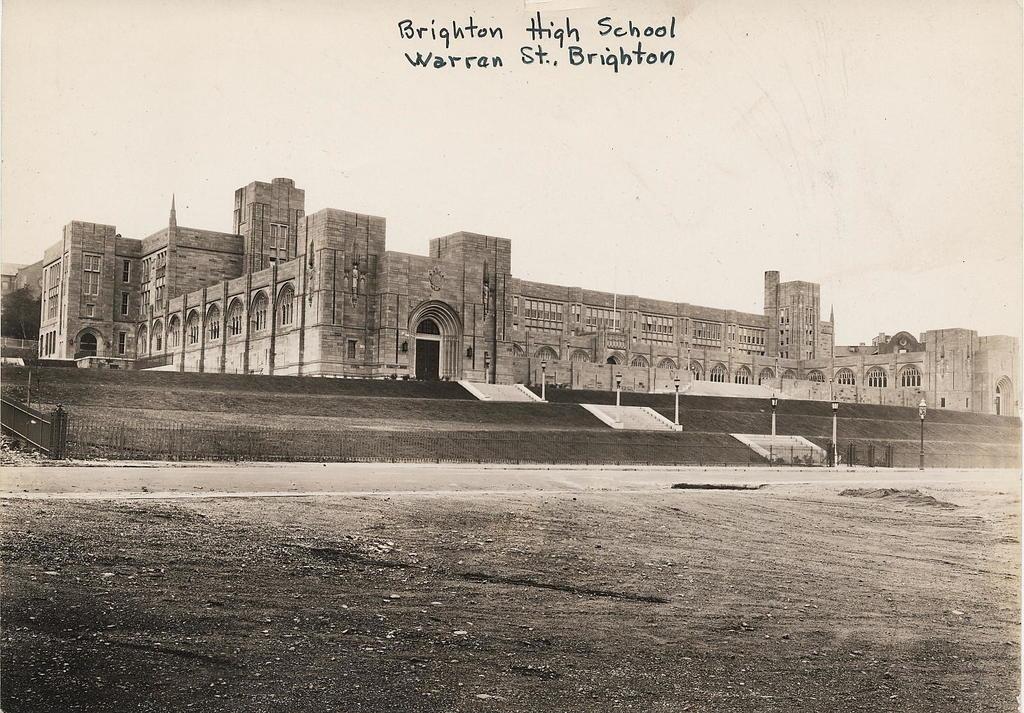What high school is this?
Offer a very short reply. Brighton high school. 